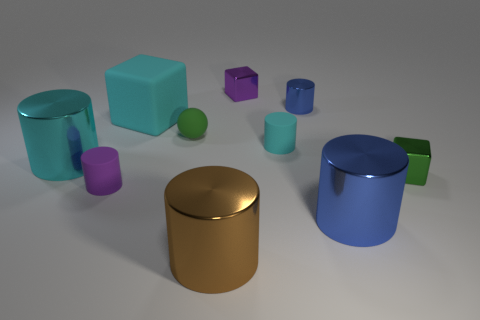Subtract all tiny purple cylinders. How many cylinders are left? 5 Subtract all red spheres. How many cyan cylinders are left? 2 Subtract 2 cylinders. How many cylinders are left? 4 Subtract all cyan blocks. How many blocks are left? 2 Subtract 1 purple cylinders. How many objects are left? 9 Subtract all spheres. How many objects are left? 9 Subtract all yellow cylinders. Subtract all red cubes. How many cylinders are left? 6 Subtract all big matte cubes. Subtract all green matte balls. How many objects are left? 8 Add 4 large cyan objects. How many large cyan objects are left? 6 Add 8 red metal blocks. How many red metal blocks exist? 8 